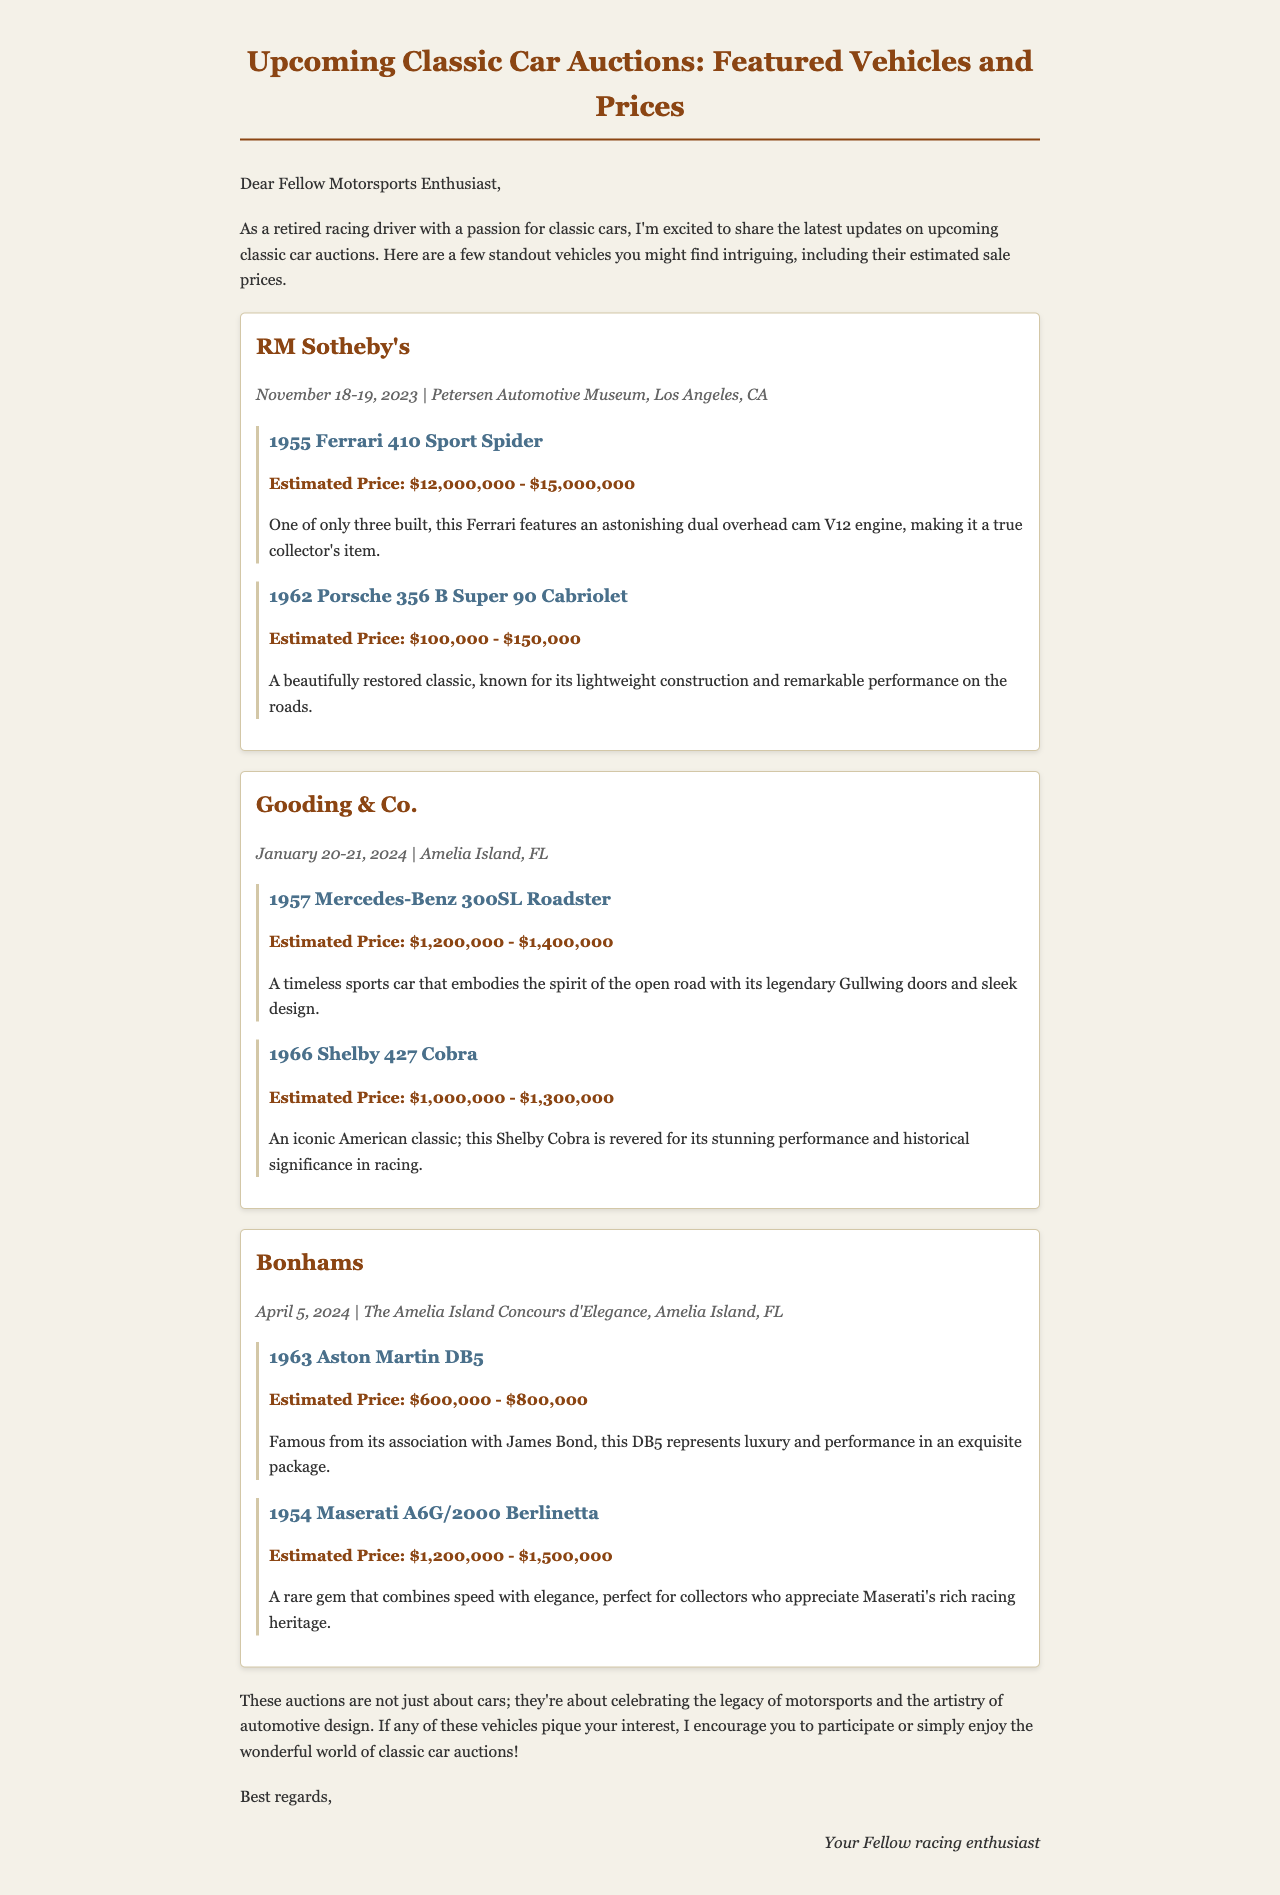What is the date of the RM Sotheby's auction? The auction is scheduled for November 18-19, 2023, as mentioned in the document.
Answer: November 18-19, 2023 What is the estimated price range for the 1955 Ferrari 410 Sport Spider? The document states that the estimated price for this vehicle is between $12,000,000 and $15,000,000.
Answer: $12,000,000 - $15,000,000 Which car is associated with James Bond? The 1963 Aston Martin DB5 is famous for its association with James Bond according to the document.
Answer: 1963 Aston Martin DB5 How many vehicles are featured in the Gooding & Co. auction? There are two vehicles listed for the Gooding & Co. auction in the document.
Answer: Two What is the auction location for Bonhams? The Bonhams auction will take place at The Amelia Island Concours d'Elegance as specified in the document.
Answer: The Amelia Island Concours d'Elegance What historical significance is noted for the 1966 Shelby 427 Cobra? The document mentions that the 1966 Shelby 427 Cobra is revered for its stunning performance and historical significance in racing.
Answer: Historical significance in racing Which auction has the earliest date mentioned? The RM Sotheby's auction occurs first in the document since it is scheduled for November 2023.
Answer: RM Sotheby's What is the price range for the 1954 Maserati A6G/2000 Berlinetta? The document indicates the estimated price range for this vehicle is between $1,200,000 and $1,500,000.
Answer: $1,200,000 - $1,500,000 